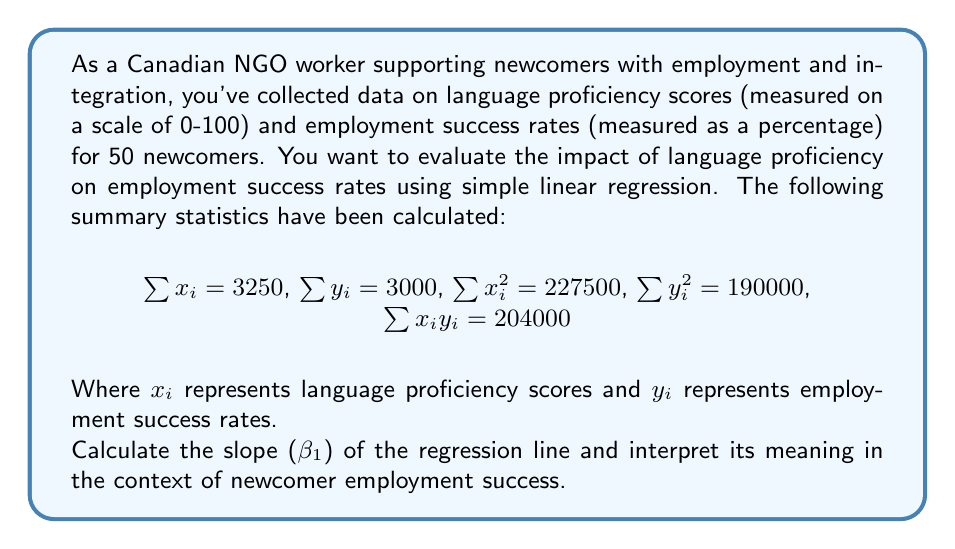Show me your answer to this math problem. To solve this problem, we'll use the formula for the slope ($\beta_1$) in simple linear regression:

$$\beta_1 = \frac{n\sum x_iy_i - \sum x_i \sum y_i}{n\sum x_i^2 - (\sum x_i)^2}$$

Where $n$ is the number of data points (50 in this case).

Step 1: Calculate the numerator
$$n\sum x_iy_i - \sum x_i \sum y_i = 50(204000) - 3250(3000) = 10200000 - 9750000 = 450000$$

Step 2: Calculate the denominator
$$n\sum x_i^2 - (\sum x_i)^2 = 50(227500) - 3250^2 = 11375000 - 10562500 = 812500$$

Step 3: Calculate $\beta_1$
$$\beta_1 = \frac{450000}{812500} = 0.5538$$

Interpretation: The slope $\beta_1 = 0.5538$ represents the change in employment success rate for each one-point increase in language proficiency score. Specifically, for every one-point increase in language proficiency score, we expect the employment success rate to increase by 0.5538 percentage points, on average.

This positive slope indicates a positive relationship between language proficiency and employment success rates for newcomers. It suggests that as language proficiency improves, the likelihood of employment success also increases.
Answer: $\beta_1 = 0.5538$

Interpretation: For every one-point increase in language proficiency score, the employment success rate is expected to increase by 0.5538 percentage points, on average. 